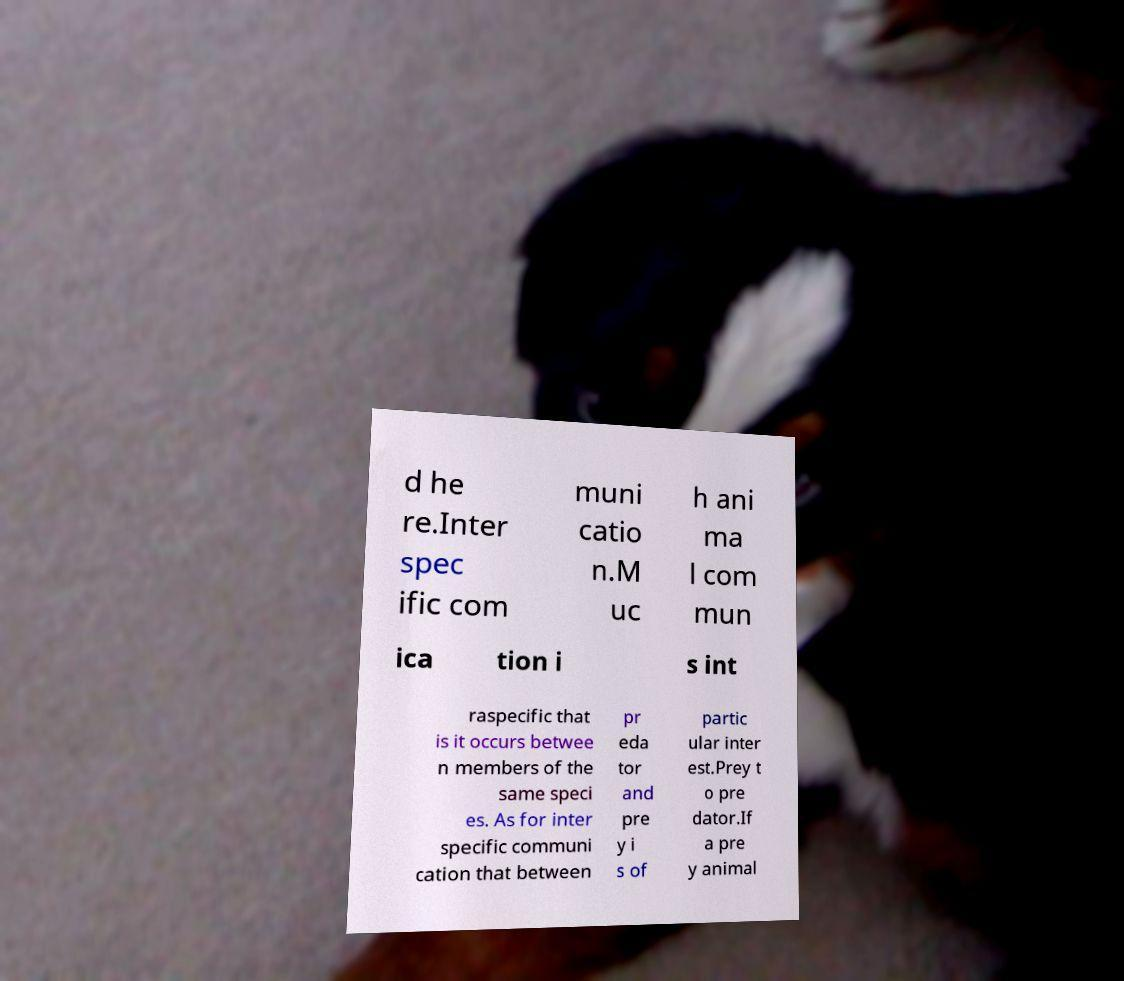I need the written content from this picture converted into text. Can you do that? d he re.Inter spec ific com muni catio n.M uc h ani ma l com mun ica tion i s int raspecific that is it occurs betwee n members of the same speci es. As for inter specific communi cation that between pr eda tor and pre y i s of partic ular inter est.Prey t o pre dator.If a pre y animal 